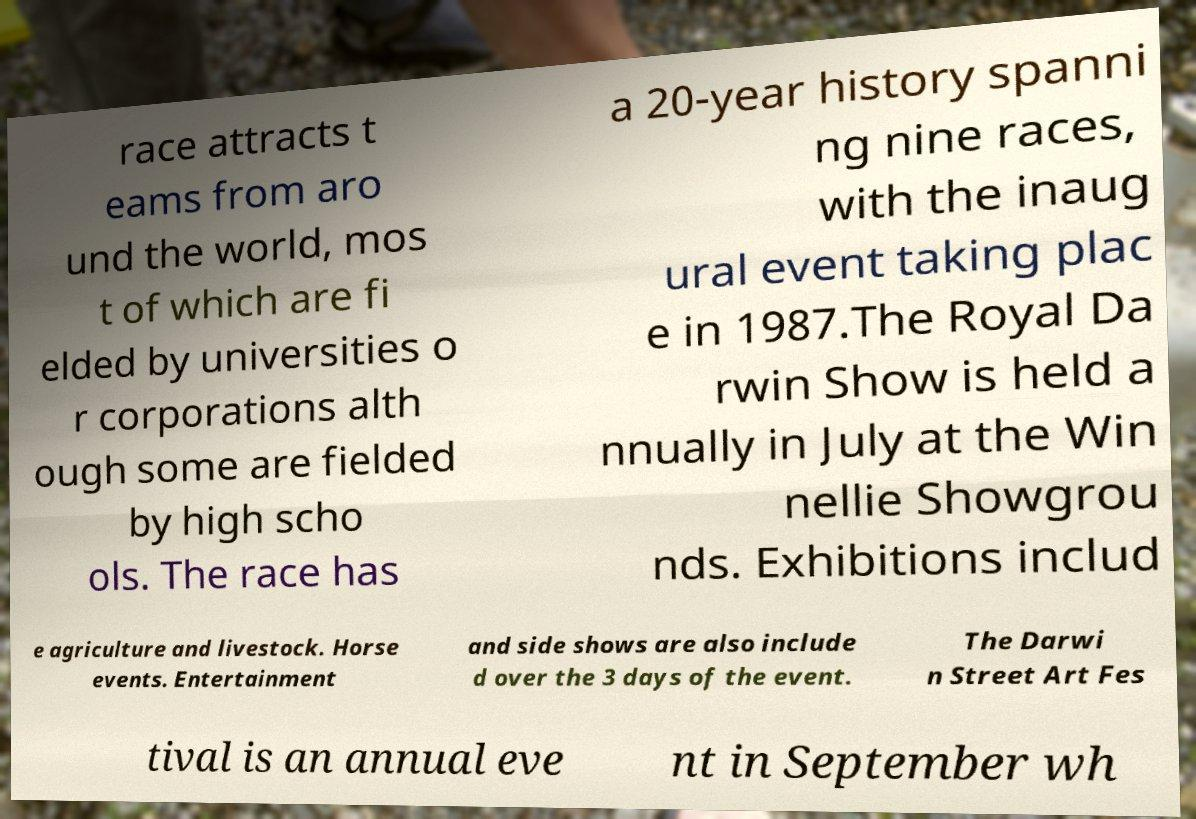Please read and relay the text visible in this image. What does it say? race attracts t eams from aro und the world, mos t of which are fi elded by universities o r corporations alth ough some are fielded by high scho ols. The race has a 20-year history spanni ng nine races, with the inaug ural event taking plac e in 1987.The Royal Da rwin Show is held a nnually in July at the Win nellie Showgrou nds. Exhibitions includ e agriculture and livestock. Horse events. Entertainment and side shows are also include d over the 3 days of the event. The Darwi n Street Art Fes tival is an annual eve nt in September wh 